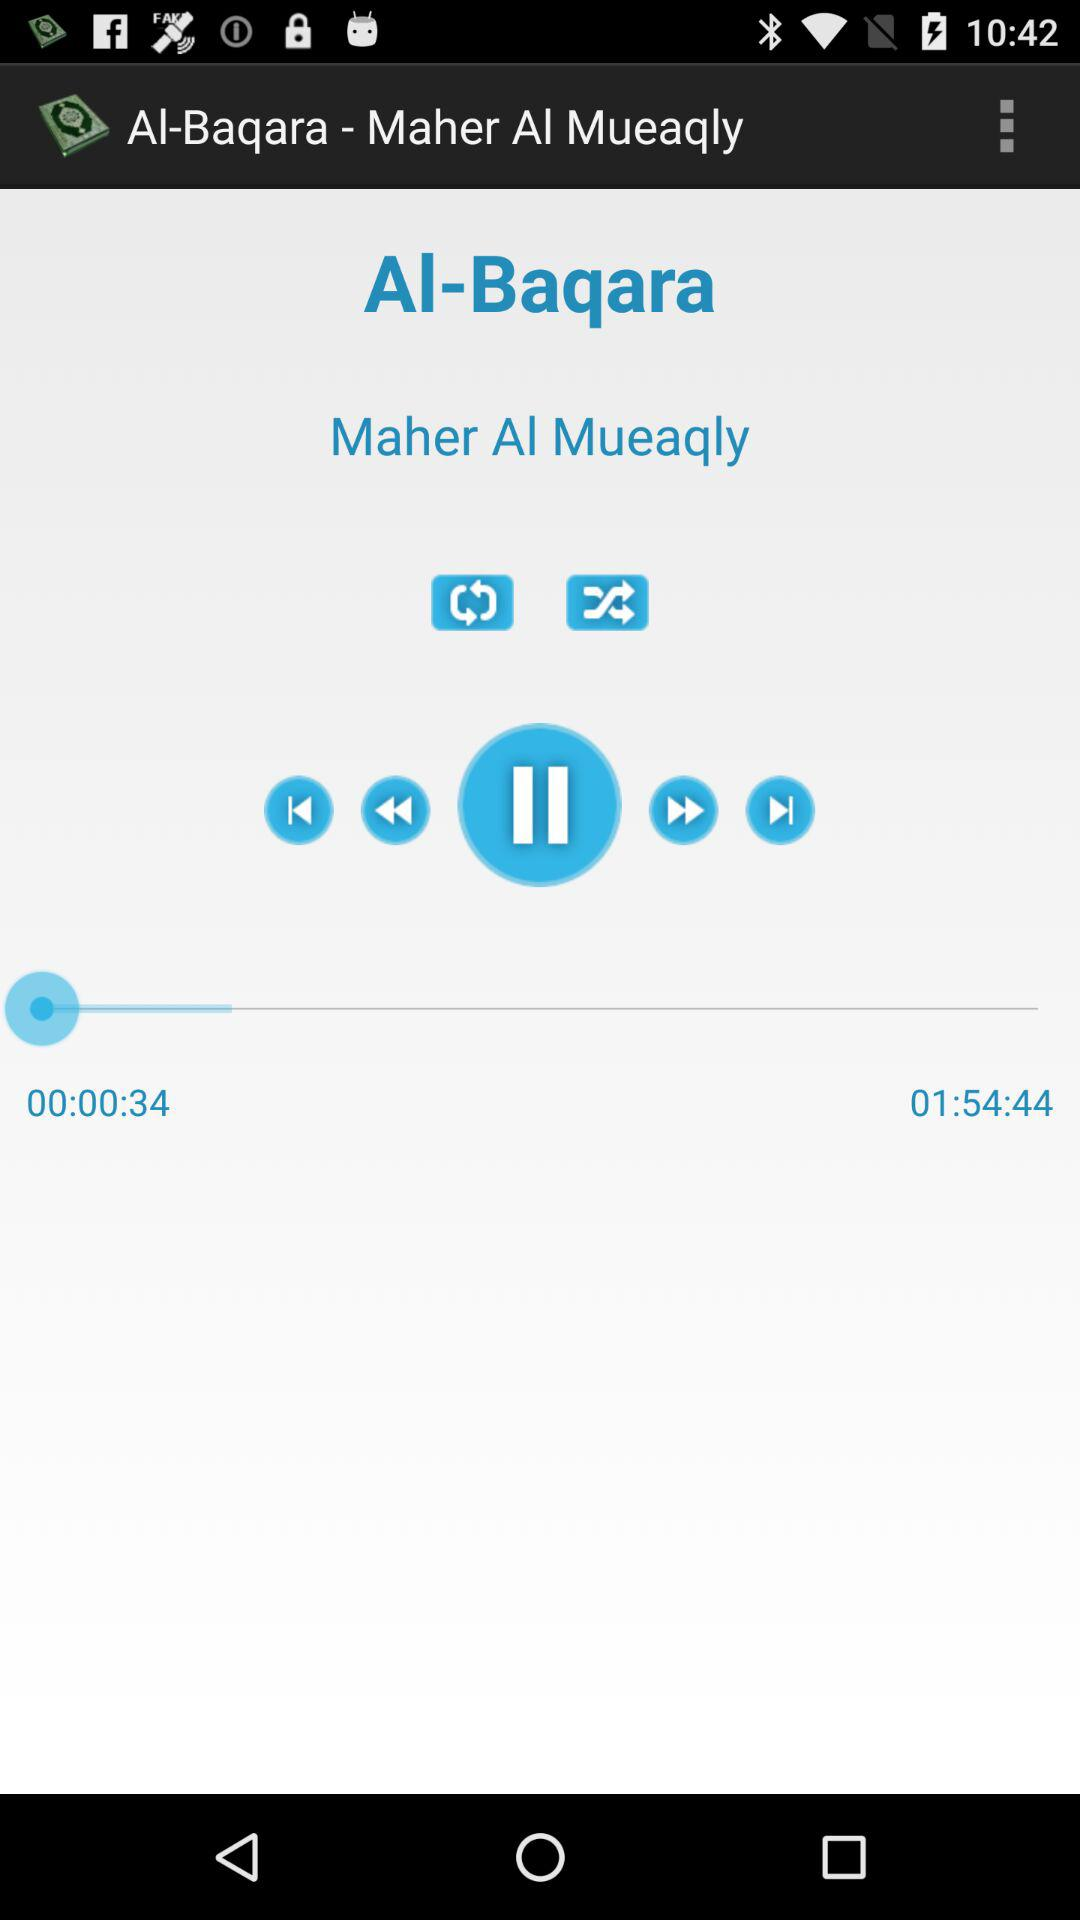What is the name of the song currently playing? The name of the song currently playing is "Al-Baqara". 